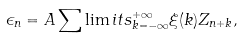<formula> <loc_0><loc_0><loc_500><loc_500>\epsilon _ { n } = A \sum \lim i t s _ { k = - \infty } ^ { + \infty } \xi ( k ) Z _ { n + k } ,</formula> 